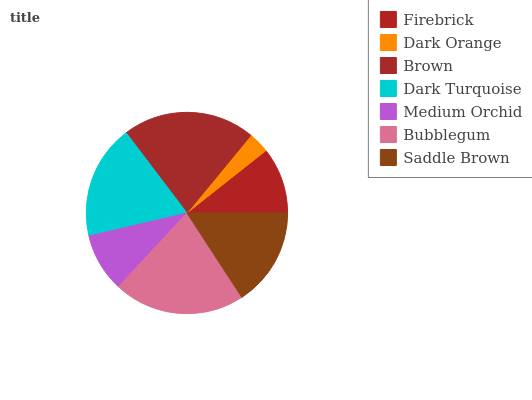Is Dark Orange the minimum?
Answer yes or no. Yes. Is Brown the maximum?
Answer yes or no. Yes. Is Brown the minimum?
Answer yes or no. No. Is Dark Orange the maximum?
Answer yes or no. No. Is Brown greater than Dark Orange?
Answer yes or no. Yes. Is Dark Orange less than Brown?
Answer yes or no. Yes. Is Dark Orange greater than Brown?
Answer yes or no. No. Is Brown less than Dark Orange?
Answer yes or no. No. Is Saddle Brown the high median?
Answer yes or no. Yes. Is Saddle Brown the low median?
Answer yes or no. Yes. Is Dark Turquoise the high median?
Answer yes or no. No. Is Brown the low median?
Answer yes or no. No. 